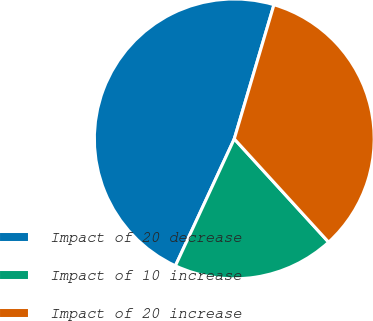<chart> <loc_0><loc_0><loc_500><loc_500><pie_chart><fcel>Impact of 20 decrease<fcel>Impact of 10 increase<fcel>Impact of 20 increase<nl><fcel>47.66%<fcel>18.69%<fcel>33.64%<nl></chart> 